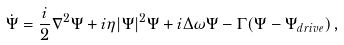Convert formula to latex. <formula><loc_0><loc_0><loc_500><loc_500>\dot { \Psi } = \frac { i } { 2 } \nabla ^ { 2 } \Psi + i \eta | \Psi | ^ { 2 } \Psi + i \Delta \omega \Psi - \Gamma ( \Psi - \Psi _ { d r i v e } ) \, ,</formula> 